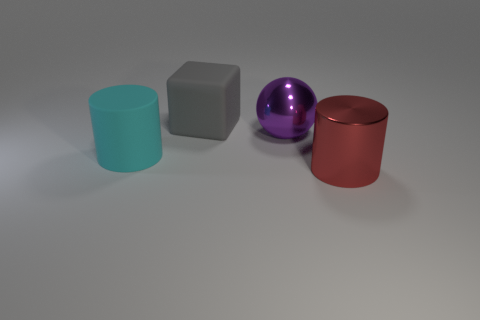Add 3 large blue shiny cylinders. How many objects exist? 7 Subtract all red cylinders. How many cylinders are left? 1 Subtract all balls. How many objects are left? 3 Subtract 2 cylinders. How many cylinders are left? 0 Subtract all cyan blocks. Subtract all brown cylinders. How many blocks are left? 1 Subtract all brown cubes. How many red cylinders are left? 1 Subtract all red metal cylinders. Subtract all big balls. How many objects are left? 2 Add 4 large cyan objects. How many large cyan objects are left? 5 Add 3 green things. How many green things exist? 3 Subtract 0 cyan cubes. How many objects are left? 4 